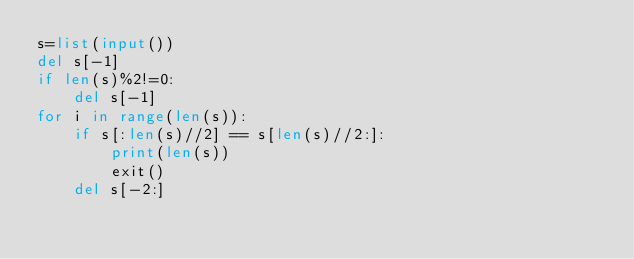Convert code to text. <code><loc_0><loc_0><loc_500><loc_500><_Python_>s=list(input())
del s[-1]
if len(s)%2!=0:
    del s[-1]
for i in range(len(s)):
    if s[:len(s)//2] == s[len(s)//2:]:
        print(len(s))
        exit()
    del s[-2:]</code> 